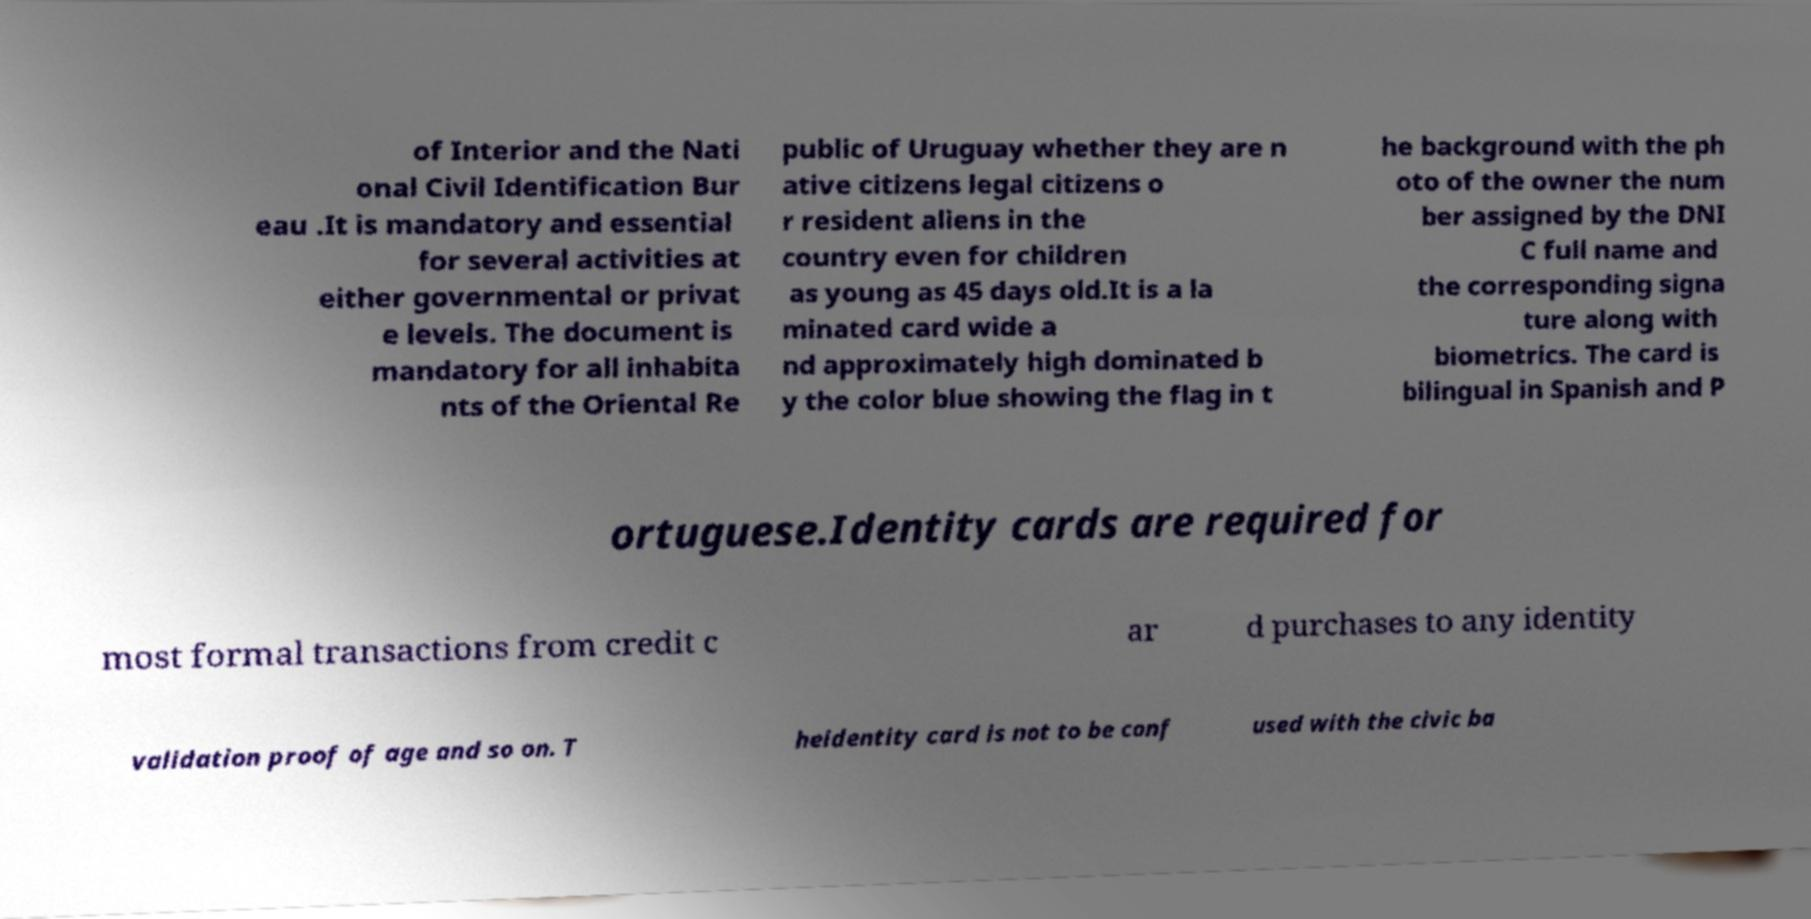There's text embedded in this image that I need extracted. Can you transcribe it verbatim? of Interior and the Nati onal Civil Identification Bur eau .It is mandatory and essential for several activities at either governmental or privat e levels. The document is mandatory for all inhabita nts of the Oriental Re public of Uruguay whether they are n ative citizens legal citizens o r resident aliens in the country even for children as young as 45 days old.It is a la minated card wide a nd approximately high dominated b y the color blue showing the flag in t he background with the ph oto of the owner the num ber assigned by the DNI C full name and the corresponding signa ture along with biometrics. The card is bilingual in Spanish and P ortuguese.Identity cards are required for most formal transactions from credit c ar d purchases to any identity validation proof of age and so on. T heidentity card is not to be conf used with the civic ba 